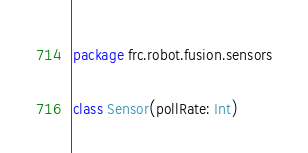Convert code to text. <code><loc_0><loc_0><loc_500><loc_500><_Kotlin_>package frc.robot.fusion.sensors

class Sensor(pollRate: Int)
</code> 